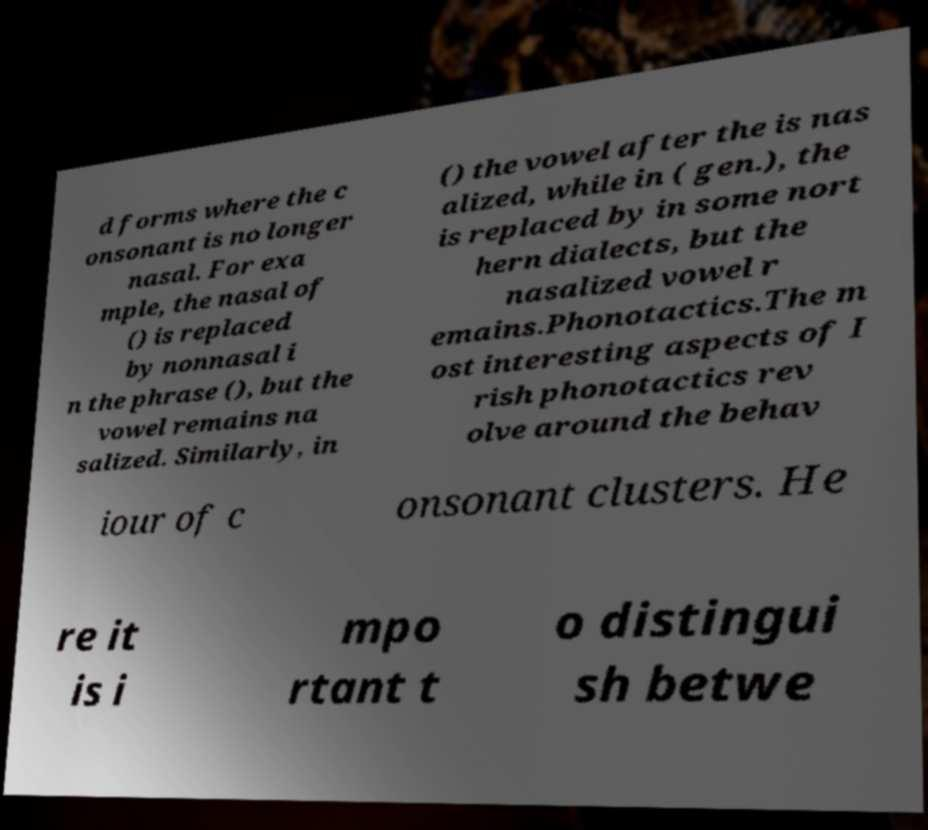For documentation purposes, I need the text within this image transcribed. Could you provide that? d forms where the c onsonant is no longer nasal. For exa mple, the nasal of () is replaced by nonnasal i n the phrase (), but the vowel remains na salized. Similarly, in () the vowel after the is nas alized, while in ( gen.), the is replaced by in some nort hern dialects, but the nasalized vowel r emains.Phonotactics.The m ost interesting aspects of I rish phonotactics rev olve around the behav iour of c onsonant clusters. He re it is i mpo rtant t o distingui sh betwe 